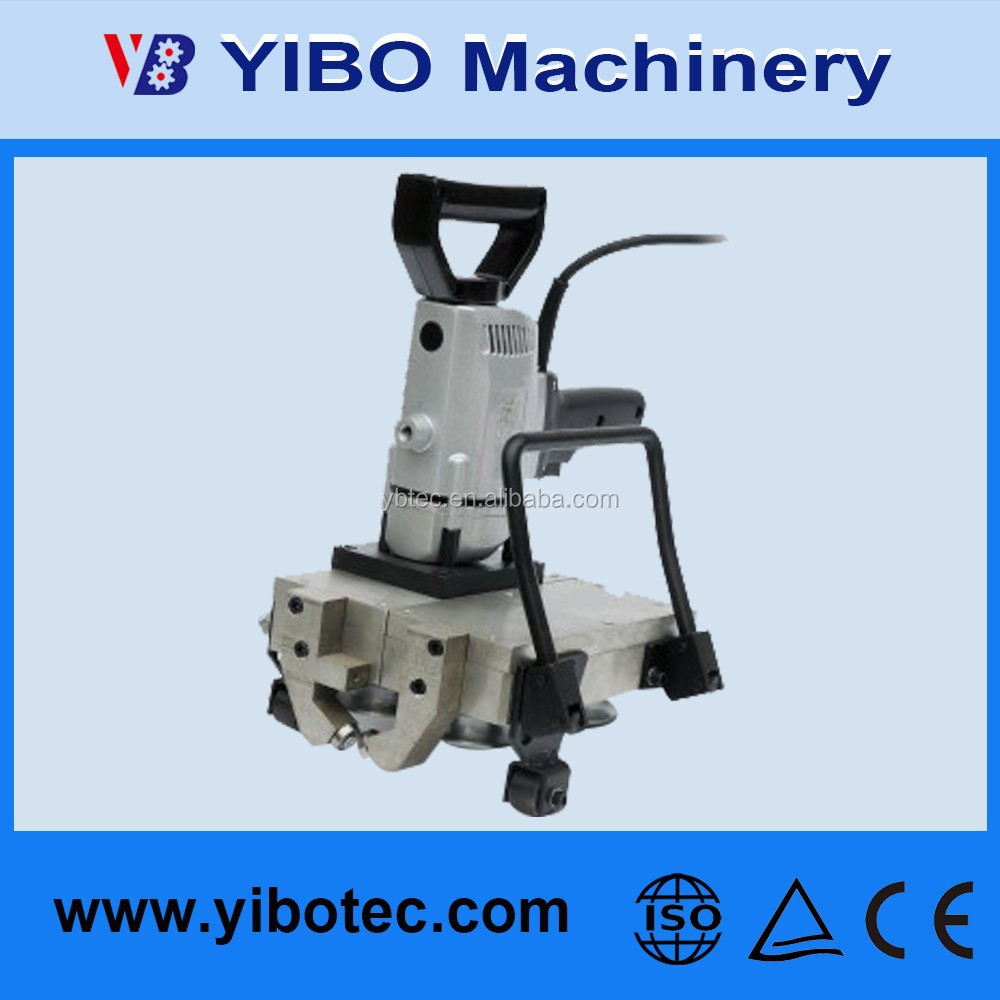Imagine that this machine has a futuristic upgrade. Describe how it might look and function in 2050. In 2050, a futuristic upgrade of this machine would likely involve advanced AI integration, enabling it to perform tasks autonomously with minimal human oversight. It might feature a sleek, modular design with enhanced ergonomics, making it easier to handle and transport. The machine could be equipped with real-time diagnostic sensors that monitor operational parameters and predict maintenance needs, ensuring optimal performance and longevity. Additionally, it might incorporate renewable energy sources such as advanced solar panels or kinetic energy converters, making it both eco-friendly and energy-efficient. Enhanced connectivity would allow seamless integration with other machinery and smart factory systems, ensuring smooth and coordinated operations. The user interface would likely be holographic, providing intuitive, touchless control and real-time data visualization. 